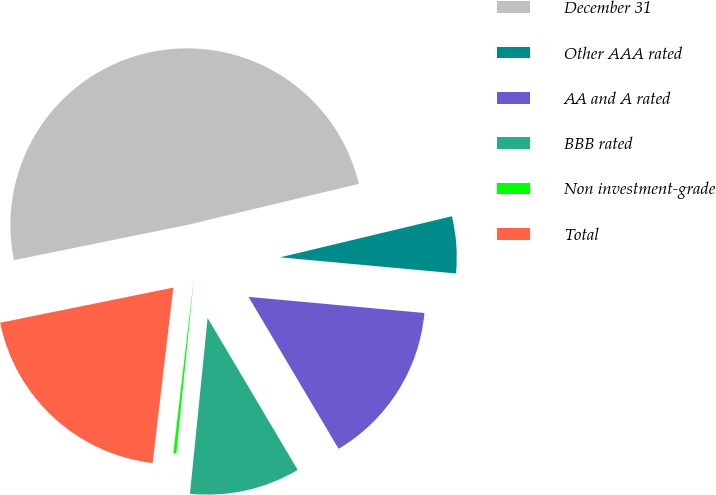Convert chart. <chart><loc_0><loc_0><loc_500><loc_500><pie_chart><fcel>December 31<fcel>Other AAA rated<fcel>AA and A rated<fcel>BBB rated<fcel>Non investment-grade<fcel>Total<nl><fcel>49.46%<fcel>5.19%<fcel>15.03%<fcel>10.11%<fcel>0.27%<fcel>19.95%<nl></chart> 